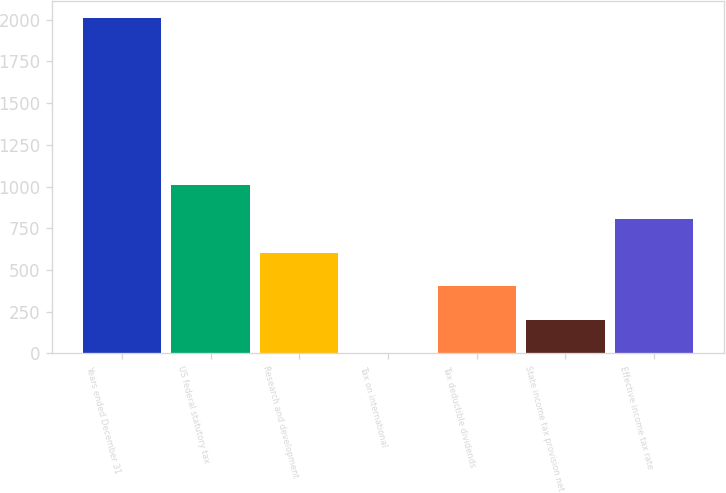Convert chart. <chart><loc_0><loc_0><loc_500><loc_500><bar_chart><fcel>Years ended December 31<fcel>US federal statutory tax<fcel>Research and development<fcel>Tax on international<fcel>Tax deductible dividends<fcel>State income tax provision net<fcel>Effective income tax rate<nl><fcel>2013<fcel>1006.55<fcel>603.97<fcel>0.1<fcel>402.68<fcel>201.39<fcel>805.26<nl></chart> 